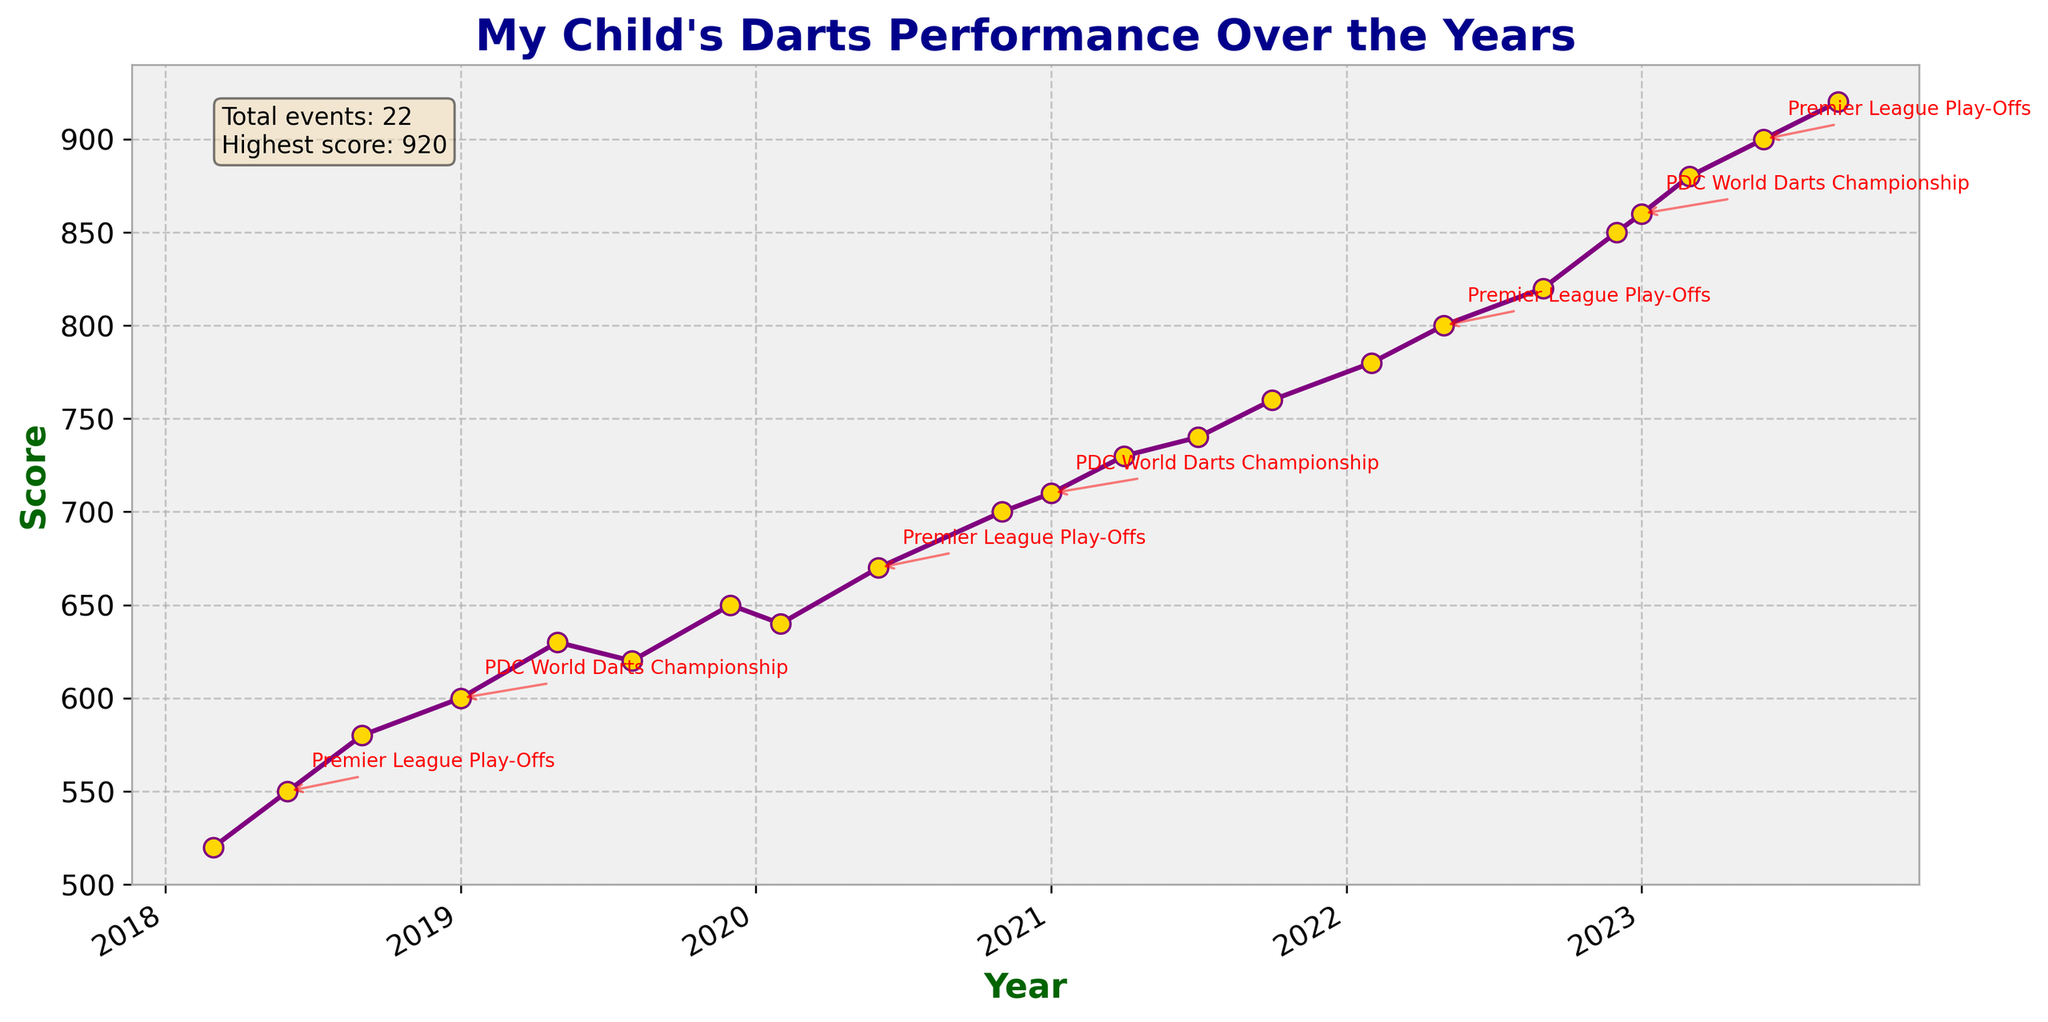What is the title of the figure? The title is typically located at the top of the figure and is meant to describe what the plot entails. In this case, the title is "My Child's Darts Performance Over the Years".
Answer: "My Child's Darts Performance Over the Years" What is the highest score achieved and in which event did it occur? The data points on the plot are marked by events and their corresponding scores. The highest score achieved is 920, which occurred at the European Championship in September 2023.
Answer: 920 at the European Championship How has the performance trend changed over the years? By observing the line plot, you can see a general upward trend in the scores from 520 in March 2018 to 920 in September 2023, indicating an improvement in performance over the years.
Answer: Upward trend How many times did your child participate in the Premier League Play-Offs, and what were the scores for each year? Locate the points labeled "Premier League Play-Offs" on the plot and note their corresponding scores and dates. The events occurred in June 2018, June 2020, May 2022, and June 2023 with scores of 550, 670, 800, and 900 respectively.
Answer: 4 times: 550 (2018), 670 (2020), 800 (2022), 900 (2023) Which year and event saw the most significant improvement in score compared to the previous event? The most significant improvement can be found by comparing the difference in scores between consecutive events. The most notable jump happens from the Players Championship Finals in December 2022 (850) to the PDC World Darts Championship in January 2023 (860), a notable but small difference. However, if we consider a broader view, from the Grand Slam of Darts in November 2020 (700) to the PDC World Darts Championship in January 2021 (710), there is also an improvement. The biggest jump within a year might be the UK Open in March 2023 (880) from the PDC World Darts Championship in January 2023 (860).
Answer: January 2023, PDC World Darts Championship (860) What events are annotated with text, and why might they be important? Annotations are added to highlight important events. The annotated events in the plot are the PDC World Darts Championship and Premier League Play-Offs, as they are major milestones in your child's career.
Answer: PDC World Darts Championship, Premier League Play-Offs What is the average score of the events taking place in the year 2023? To find the average score, sum the scores of the events in 2023 and divide by the number of events. The scores are 860 (January), 880 (March), 900 (June), and 920 (September). The average score is (860+880+900+920)/4.
Answer: 890 Which event in 2022 had the lowest score, and what was it? Identify all the events in 2022 and their scores. The scores are 780 (Masters, February), 800 (Premier League Play-Offs, May), 820 (World Cup of Darts, September), and 850 (Players Championship Finals, December). The lowest score is 780 at the Masters.
Answer: 780 at the Masters What does the text box on the plot indicate? The text box usually contains additional important information. It indicates that the total number of events is 24 and the highest score is 920.
Answer: Total events: 24, Highest score: 920 